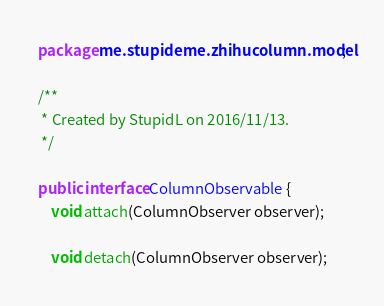Convert code to text. <code><loc_0><loc_0><loc_500><loc_500><_Java_>package me.stupideme.zhihucolumn.model;

/**
 * Created by StupidL on 2016/11/13.
 */

public interface ColumnObservable {
    void attach(ColumnObserver observer);

    void detach(ColumnObserver observer);
</code> 